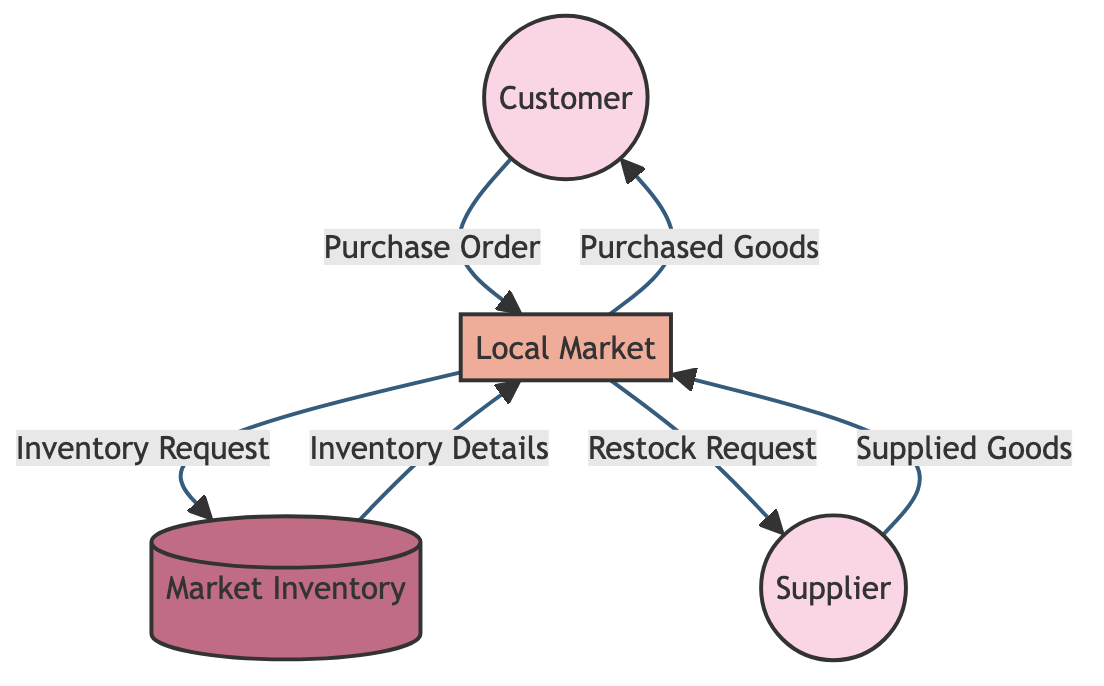What is the first entity that interacts with the Local Market? The first entity that interacts with the Local Market is the Customer, as indicated by the arrow that points from Customer to Local Market with a label of "Purchase Order."
Answer: Customer How many data flows are there in total? By counting all the arrows in the diagram, we can see there are six data flows depicted, each representing a directed flow of information between entities or processes.
Answer: 6 What data does the Supplier send to the Local Market? The Supplier sends a "Supplied Goods" data flow to the Local Market, as shown by the arrow going from Supplier to Local Market, which is labeled accordingly.
Answer: Supplied Goods What does the Local Market send to the Market Inventory? The Local Market sends an "Inventory Request" to the Market Inventory, indicated by the arrow pointing from Local Market to Market Inventory with that specific label.
Answer: Inventory Request What is the last data flow in the diagram? The last data flow in the diagram is from Local Market to Customer, with the label "Purchased Goods", indicating the final step in the transaction process.
Answer: Purchased Goods Which entity is classified as a Data Store? The Market Inventory is classified as a Data Store, as indicated by its representation in the diagram, which is styled differently to denote that it is a storage component.
Answer: Market Inventory What type of entity is the Local Market? The Local Market is classified as a Process since it indicates a series of operations performed on the data flows in the diagram, is visually represented as a process node.
Answer: Process What data flow happens after the Inventory Details are sent back to the Local Market? After the Inventory Details are sent back to the Local Market, the Local Market sends a "Restock Request" to the Supplier. This is shown by tracing the flow from Market Inventory back to Local Market, followed by the next arrow leading to Supplier.
Answer: Restock Request What type of relationship exists between the Customer and the Local Market? The relationship between the Customer and the Local Market is a communication or transaction relationship, as indicated by the directed flow of Purchase Order from the Customer to the Local Market in the diagram.
Answer: Transaction 